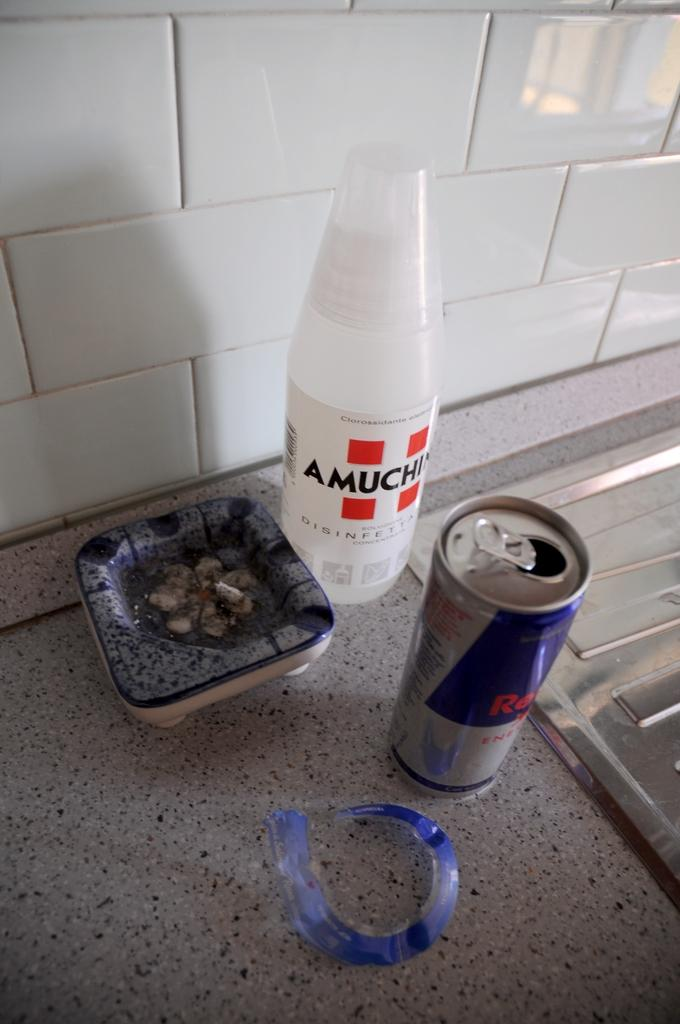Provide a one-sentence caption for the provided image. White Amuchin bottle next to an open Red Bull. 